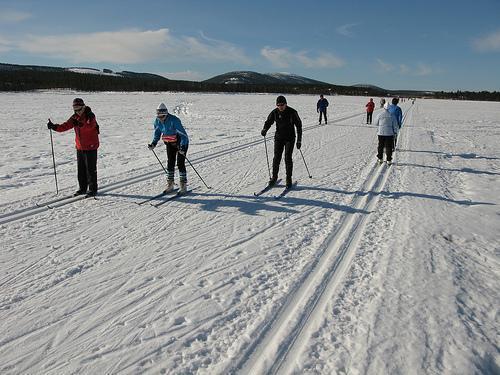How many people in red jackets?
Give a very brief answer. 2. 